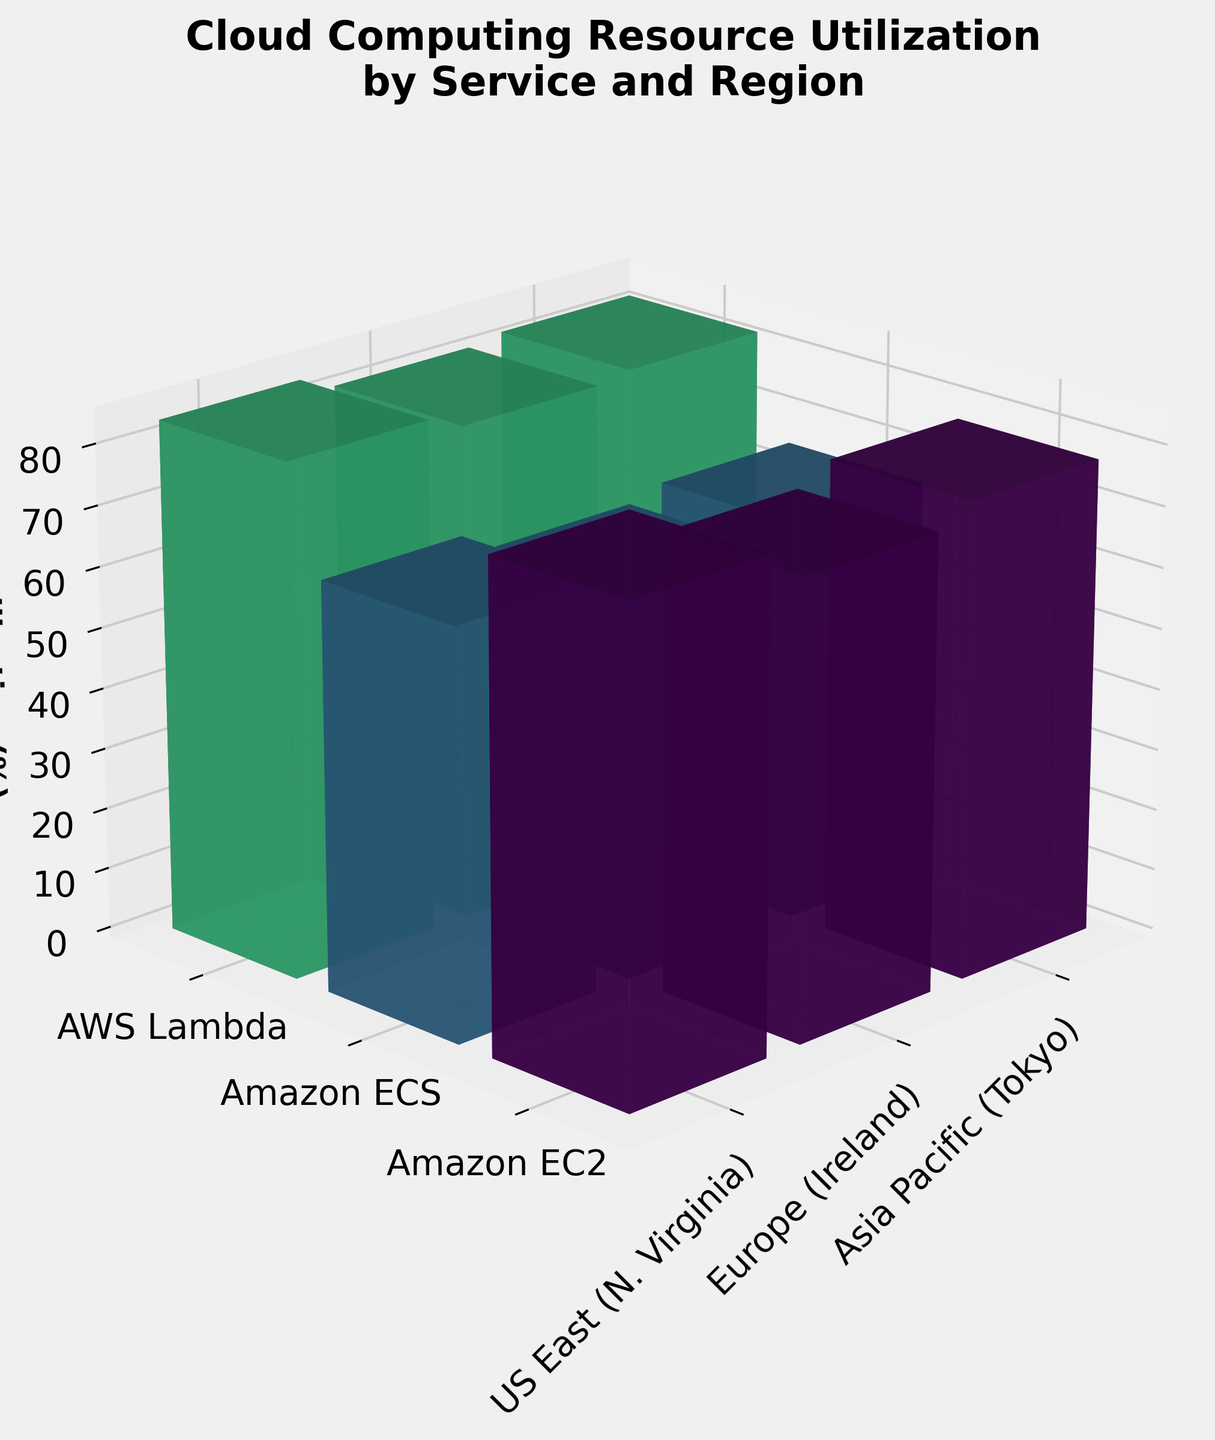What is the title of the 3D bar plot? The title of the 3D bar plot is stated at the top of the visual representation. It reads "Cloud Computing Resource Utilization by Service and Region."
Answer: Cloud Computing Resource Utilization by Service and Region Which service had the highest average utilization across all regions in Q1 2023? To determine this, we need to visually analyze the height of the bars for each service across all regions in Q1 2023. AWS Lambda has the highest average utilization as its bars are generally taller than those for Amazon EC2 and Amazon ECS.
Answer: AWS Lambda How does the utilization of Amazon ECS in Europe (Ireland) compare between Q1 2023 and Q2 2023? Comparing bars for Amazon ECS in Europe (Ireland) across quarters shows that the utilization increased from Q1 2023 to Q2 2023.
Answer: Increased What's the difference in utilization percentage between AWS Lambda in US East (N. Virginia) and Amazon ECS in US East (N. Virginia) for Q2 2023? Look at the height of bars for AWS Lambda and Amazon ECS in US East (N. Virginia) in Q2 2023. AWS Lambda is at 85.9% and Amazon ECS is at 68.7%. The difference is 85.9 - 68.7 = 17.2%.
Answer: 17.2% Across all services, which region shows the lowest average utilization? By considering the height of individual bars for all services within each region, Europe (Ireland) consistently has shorter bars compared to US East (N. Virginia) and Asia Pacific (Tokyo), indicating lower average utilization.
Answer: Europe (Ireland) What is the overall average utilization of Amazon EC2 across all regions in Q1 2023? To get the average, sum the utilizations of Amazon EC2 in each region for Q1 2023 and divide by the number of regions: (78.5 + 72.3 + 75.9) / 3 = 226.7 / 3 = 75.57.
Answer: 75.57% In Q2 2023, which region observed the highest utilization from AWS Lambda? By analyzing the height of bars for AWS Lambda across regions in Q2 2023, the US East (N. Virginia) has the tallest bar at 85.9%, indicating the highest utilization.
Answer: US East (N. Virginia) Compare the average utilization of Amazon EC2 services between Q1 2023 and Q2 2023. Calculate the average in each quarter then compare. Q1 2023: (78.5 + 72.3 + 75.9) / 3 = 75.57. Q2 2023: (81.2 + 76.9 + 79.4) / 3 = 79.17. Comparison shows an increase.
Answer: Increased Which quarter shows a higher overall average utilization for AWS Lambda across all regions? Calculate the average for each quarter and compare. Q1 2023: (82.1 + 79.6 + 80.3) / 3 = 80.67. Q2 2023: (85.9 + 83.2 + 84.6) / 3 = 84.57. Q2 2023 has the higher average.
Answer: Q2 2023 